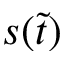Convert formula to latex. <formula><loc_0><loc_0><loc_500><loc_500>s ( \widetilde { t } )</formula> 